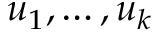Convert formula to latex. <formula><loc_0><loc_0><loc_500><loc_500>u _ { 1 } , \dots , u _ { k }</formula> 